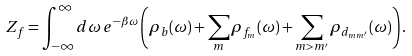Convert formula to latex. <formula><loc_0><loc_0><loc_500><loc_500>Z _ { f } = \int _ { - \infty } ^ { \infty } d \omega \, e ^ { - \beta \omega } \left ( \rho _ { b } ( \omega ) + \sum _ { m } \rho _ { f _ { m } } ( \omega ) + \sum _ { m > m ^ { \prime } } \rho _ { d _ { m m ^ { \prime } } } ( \omega ) \right ) .</formula> 